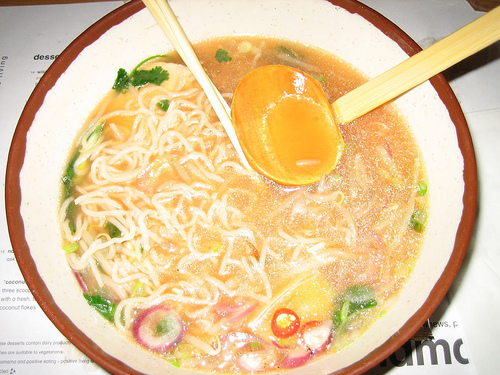<image>
Is there a bowl next to the spoon? No. The bowl is not positioned next to the spoon. They are located in different areas of the scene. 